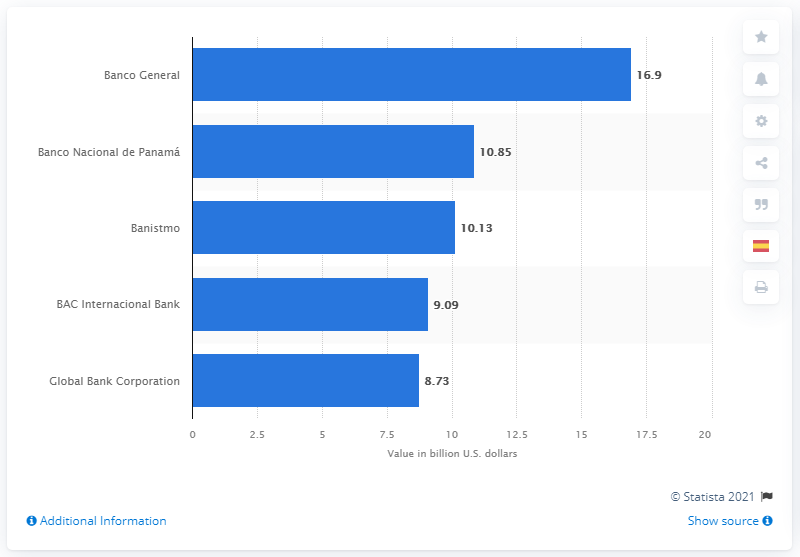Outline some significant characteristics in this image. According to the assets of Banco Nacional de Panam in 2019, the value was approximately 10.85... In 2019, the total assets of Banco Central were worth 16.9 billion US dollars. 